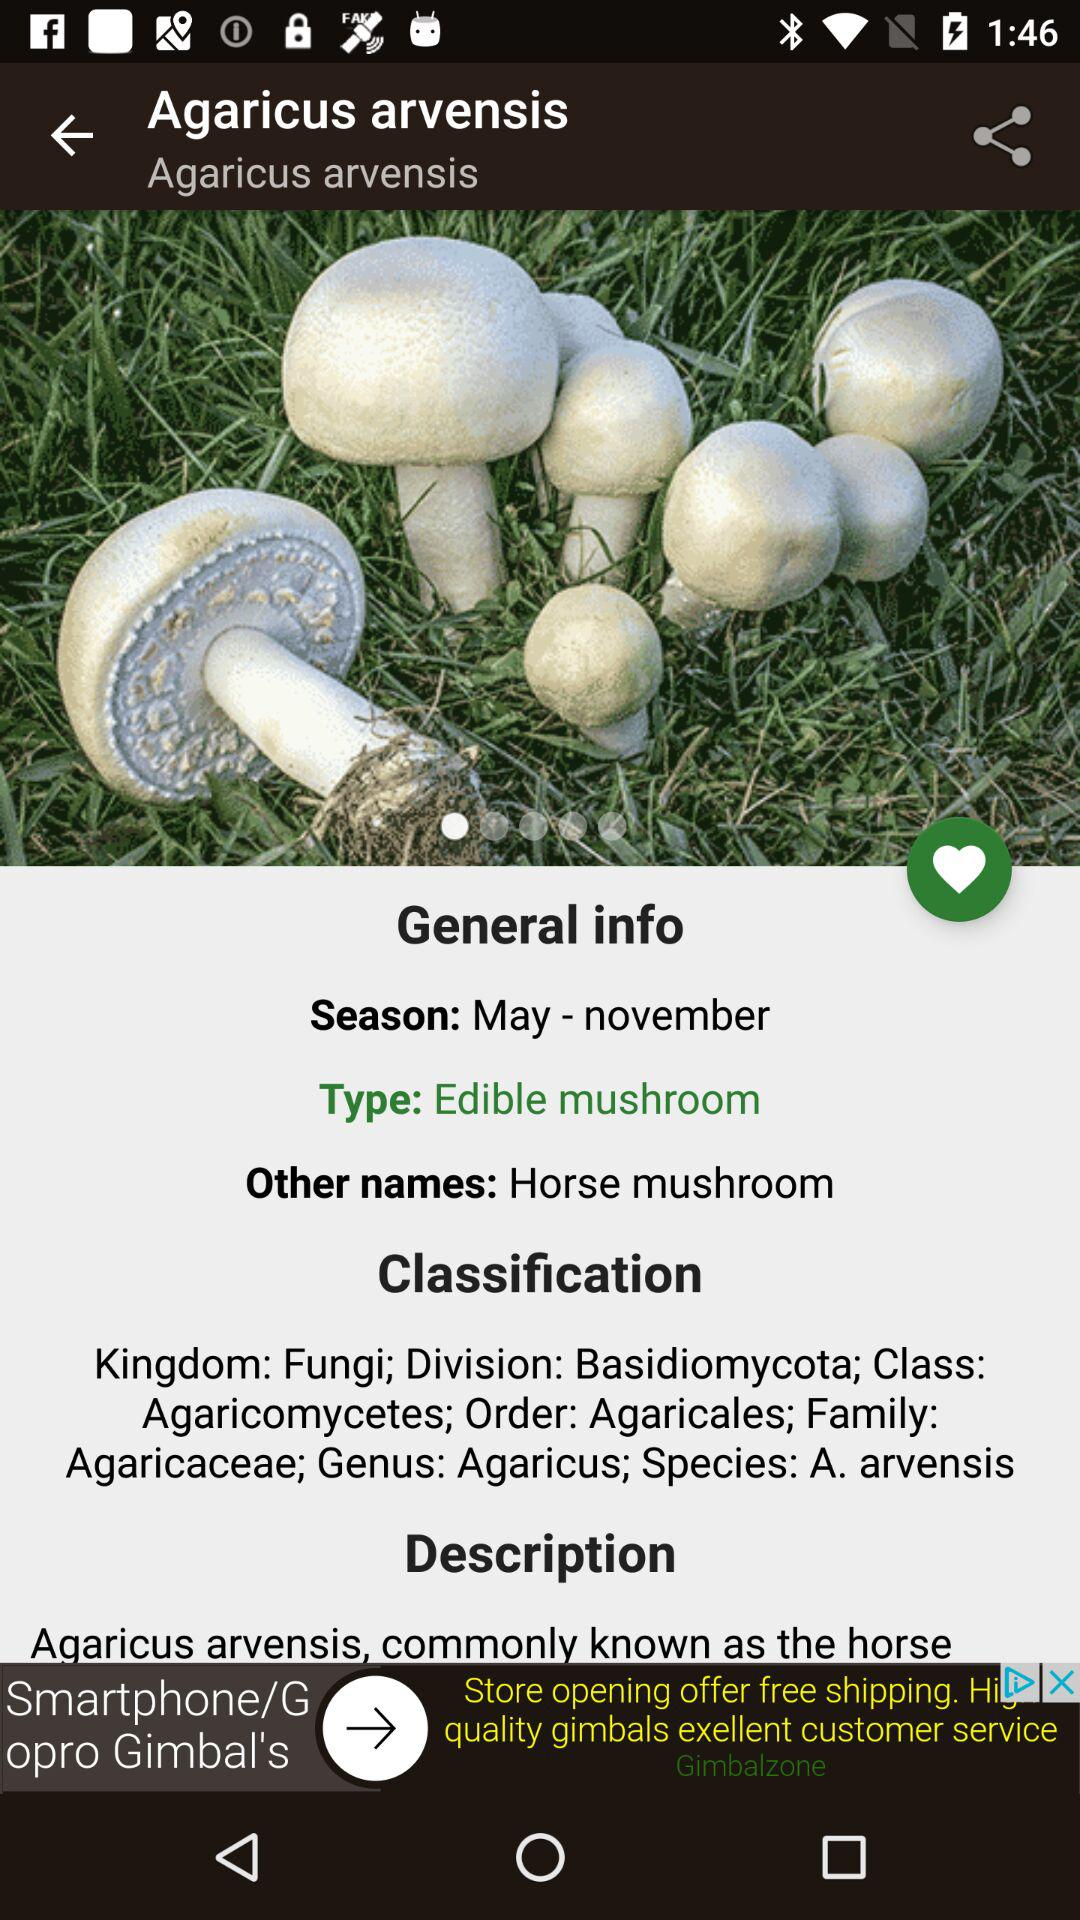What type of mushroom is "Agaricus arvensis mushroom"? The type is "Edible mushroom". 